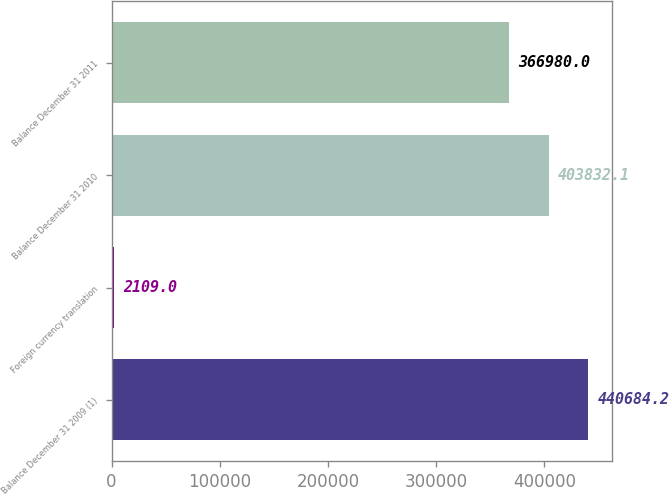Convert chart. <chart><loc_0><loc_0><loc_500><loc_500><bar_chart><fcel>Balance December 31 2009 (1)<fcel>Foreign currency translation<fcel>Balance December 31 2010<fcel>Balance December 31 2011<nl><fcel>440684<fcel>2109<fcel>403832<fcel>366980<nl></chart> 